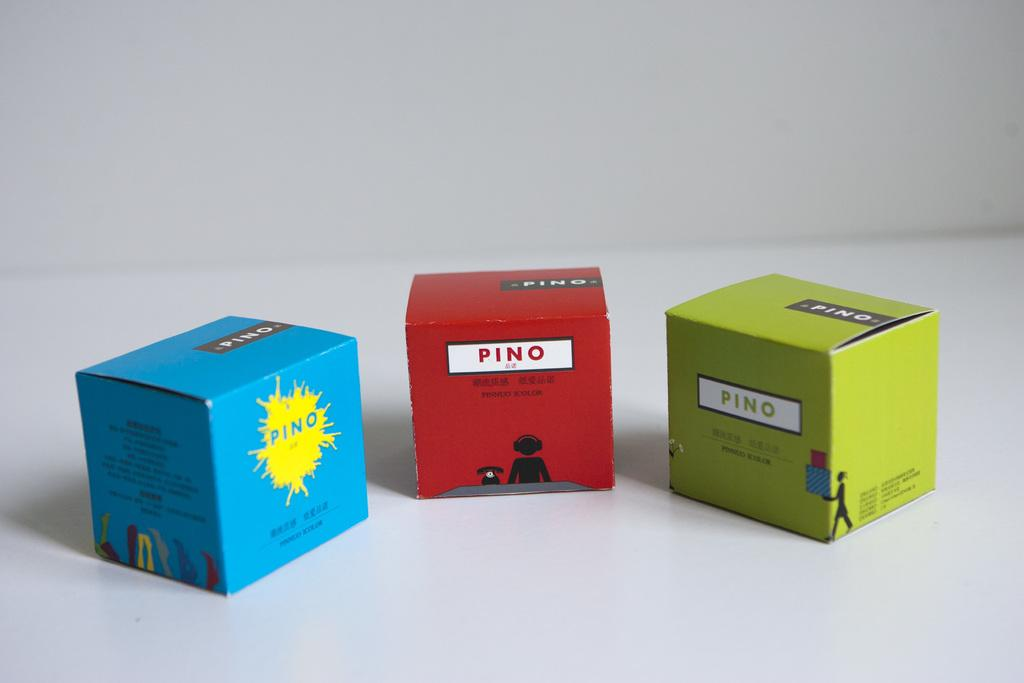<image>
Give a short and clear explanation of the subsequent image. three colorful box's of Pino sit in a row against a white background 